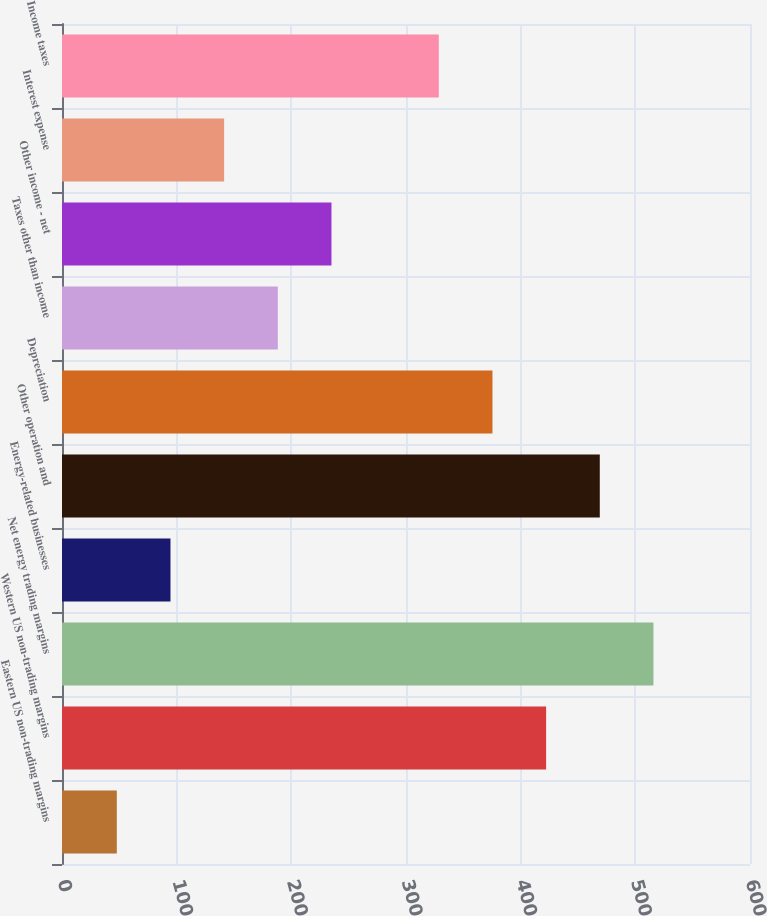Convert chart. <chart><loc_0><loc_0><loc_500><loc_500><bar_chart><fcel>Eastern US non-trading margins<fcel>Western US non-trading margins<fcel>Net energy trading margins<fcel>Energy-related businesses<fcel>Other operation and<fcel>Depreciation<fcel>Taxes other than income<fcel>Other income - net<fcel>Interest expense<fcel>Income taxes<nl><fcel>47.8<fcel>422.2<fcel>515.8<fcel>94.6<fcel>469<fcel>375.4<fcel>188.2<fcel>235<fcel>141.4<fcel>328.6<nl></chart> 